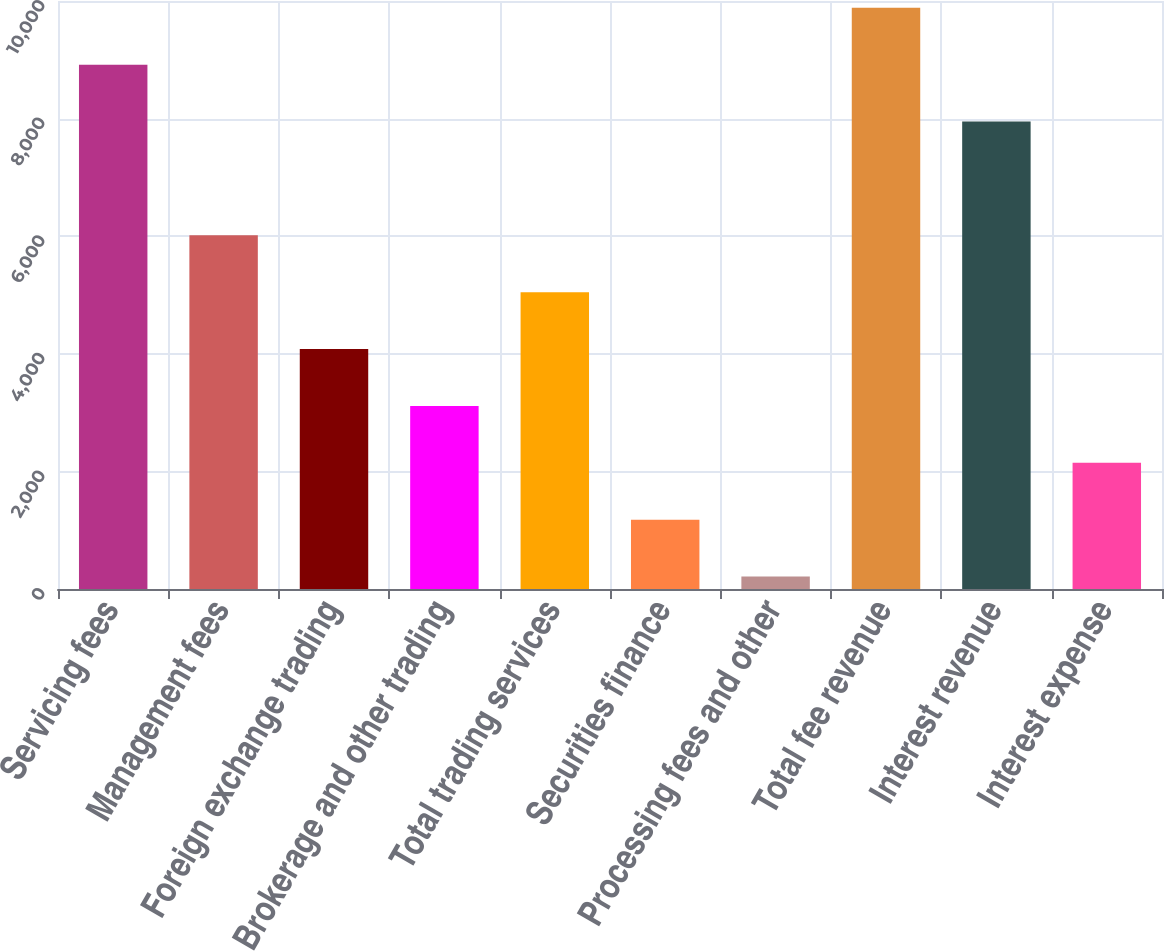Convert chart to OTSL. <chart><loc_0><loc_0><loc_500><loc_500><bar_chart><fcel>Servicing fees<fcel>Management fees<fcel>Foreign exchange trading<fcel>Brokerage and other trading<fcel>Total trading services<fcel>Securities finance<fcel>Processing fees and other<fcel>Total fee revenue<fcel>Interest revenue<fcel>Interest expense<nl><fcel>8916.8<fcel>6015.2<fcel>4080.8<fcel>3113.6<fcel>5048<fcel>1179.2<fcel>212<fcel>9884<fcel>7949.6<fcel>2146.4<nl></chart> 